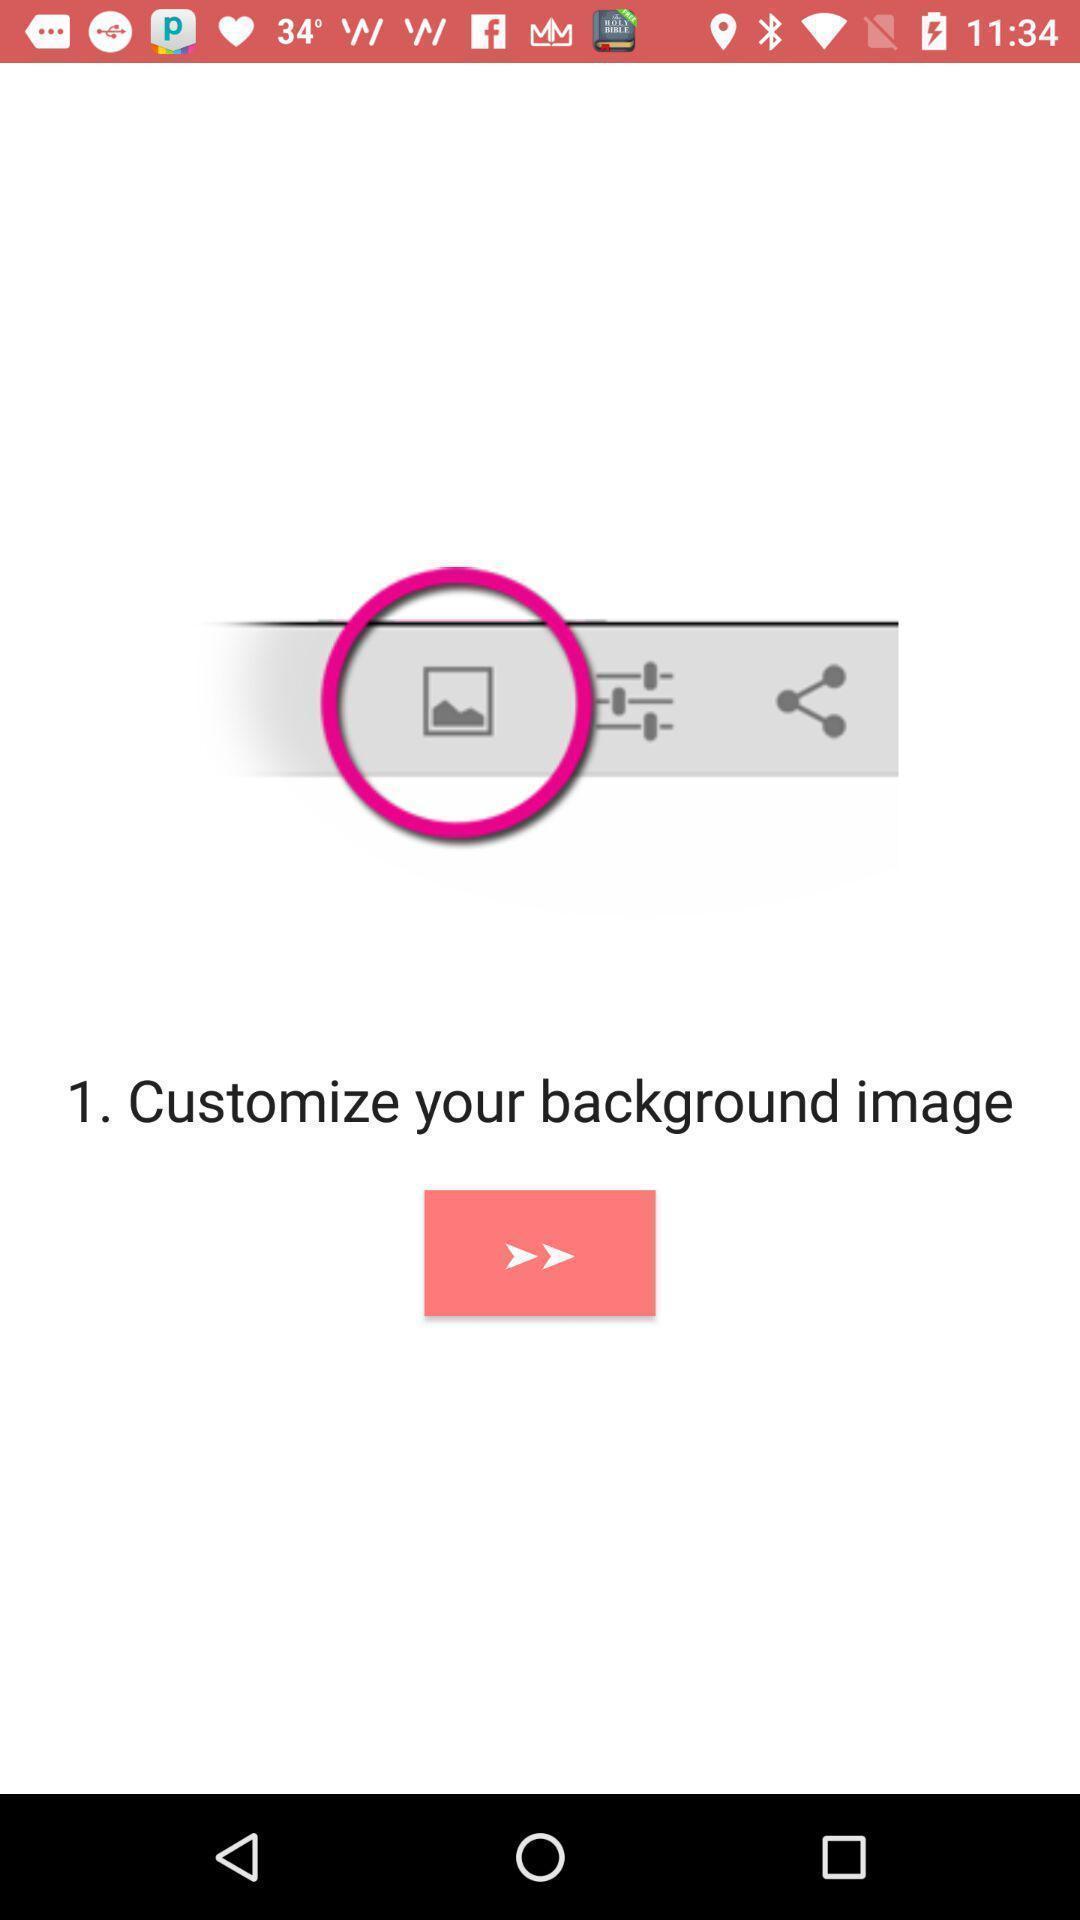Explain what's happening in this screen capture. Page to customize your background in a couple app. 